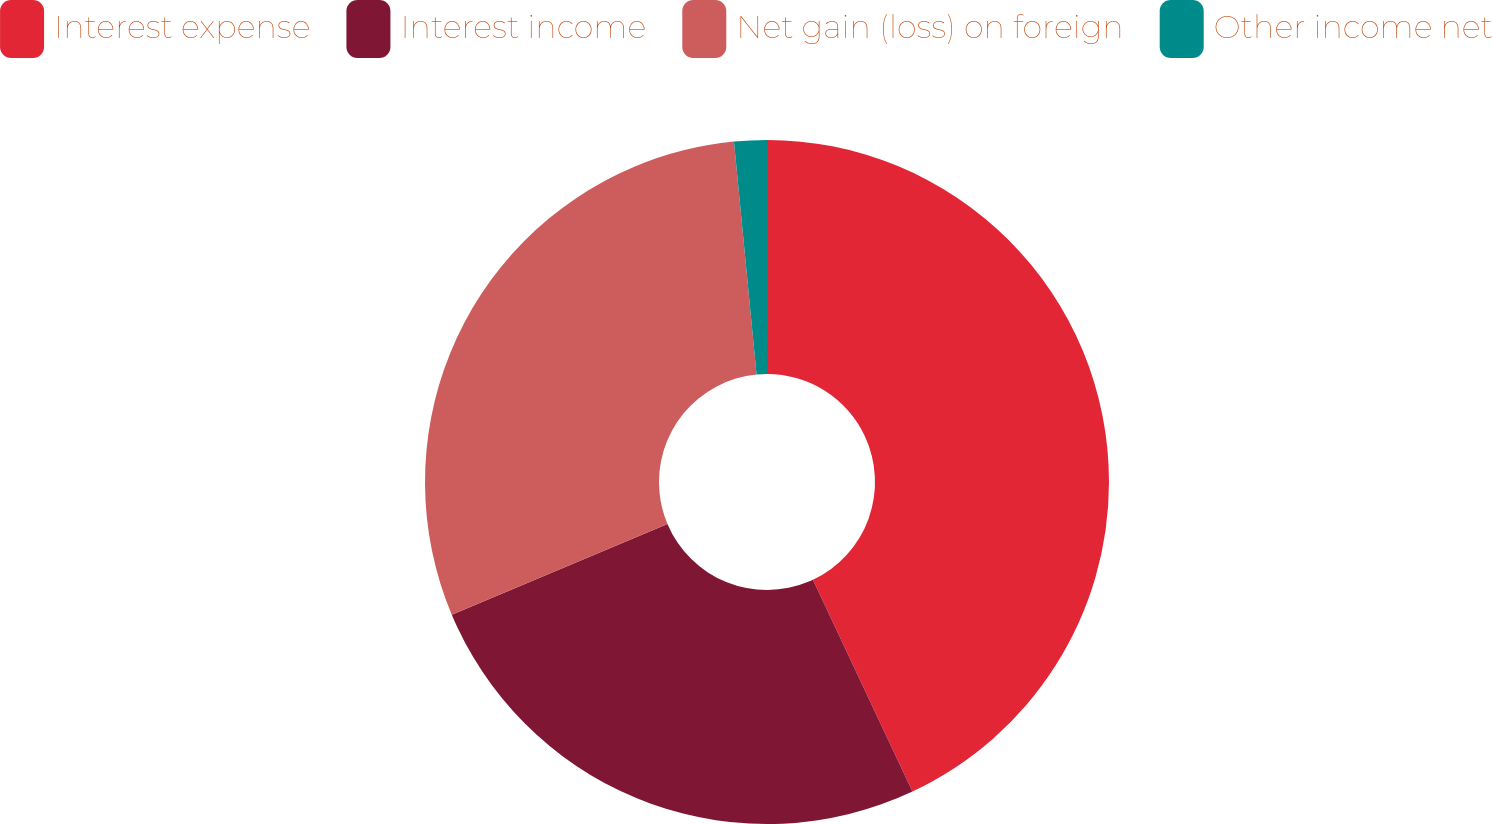Convert chart. <chart><loc_0><loc_0><loc_500><loc_500><pie_chart><fcel>Interest expense<fcel>Interest income<fcel>Net gain (loss) on foreign<fcel>Other income net<nl><fcel>43.01%<fcel>25.65%<fcel>29.8%<fcel>1.54%<nl></chart> 